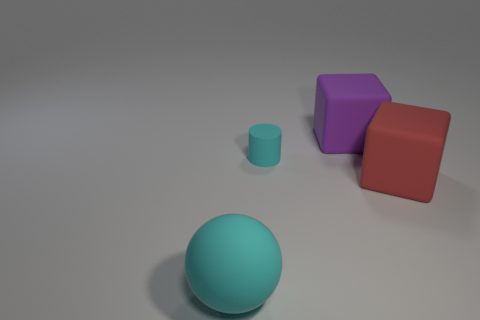Are there any other things that have the same size as the matte cylinder?
Ensure brevity in your answer.  No. There is a cyan thing that is on the right side of the ball; does it have the same size as the cyan rubber sphere?
Ensure brevity in your answer.  No. There is a cyan thing in front of the big red matte thing in front of the small matte cylinder; what number of matte things are behind it?
Your answer should be compact. 3. There is a matte thing that is both to the left of the large red cube and in front of the tiny cyan rubber cylinder; what size is it?
Make the answer very short. Large. How many other things are there of the same shape as the big purple matte thing?
Offer a very short reply. 1. How many big cyan objects are behind the large purple cube?
Your response must be concise. 0. Are there fewer cyan matte spheres that are to the right of the tiny cylinder than large things in front of the big purple rubber object?
Your answer should be very brief. Yes. There is a matte object on the left side of the cyan rubber thing on the right side of the cyan object in front of the small matte thing; what is its shape?
Provide a short and direct response. Sphere. The big object that is in front of the big purple cube and on the right side of the cyan matte sphere has what shape?
Your answer should be very brief. Cube. Is there a cube that has the same material as the sphere?
Provide a succinct answer. Yes. 